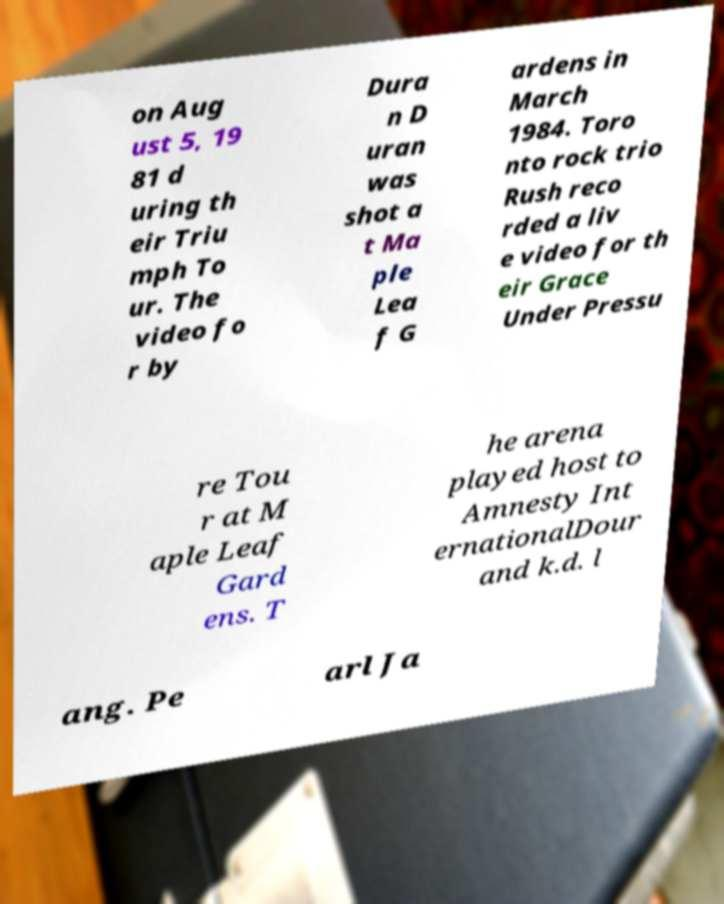I need the written content from this picture converted into text. Can you do that? on Aug ust 5, 19 81 d uring th eir Triu mph To ur. The video fo r by Dura n D uran was shot a t Ma ple Lea f G ardens in March 1984. Toro nto rock trio Rush reco rded a liv e video for th eir Grace Under Pressu re Tou r at M aple Leaf Gard ens. T he arena played host to Amnesty Int ernationalDour and k.d. l ang. Pe arl Ja 